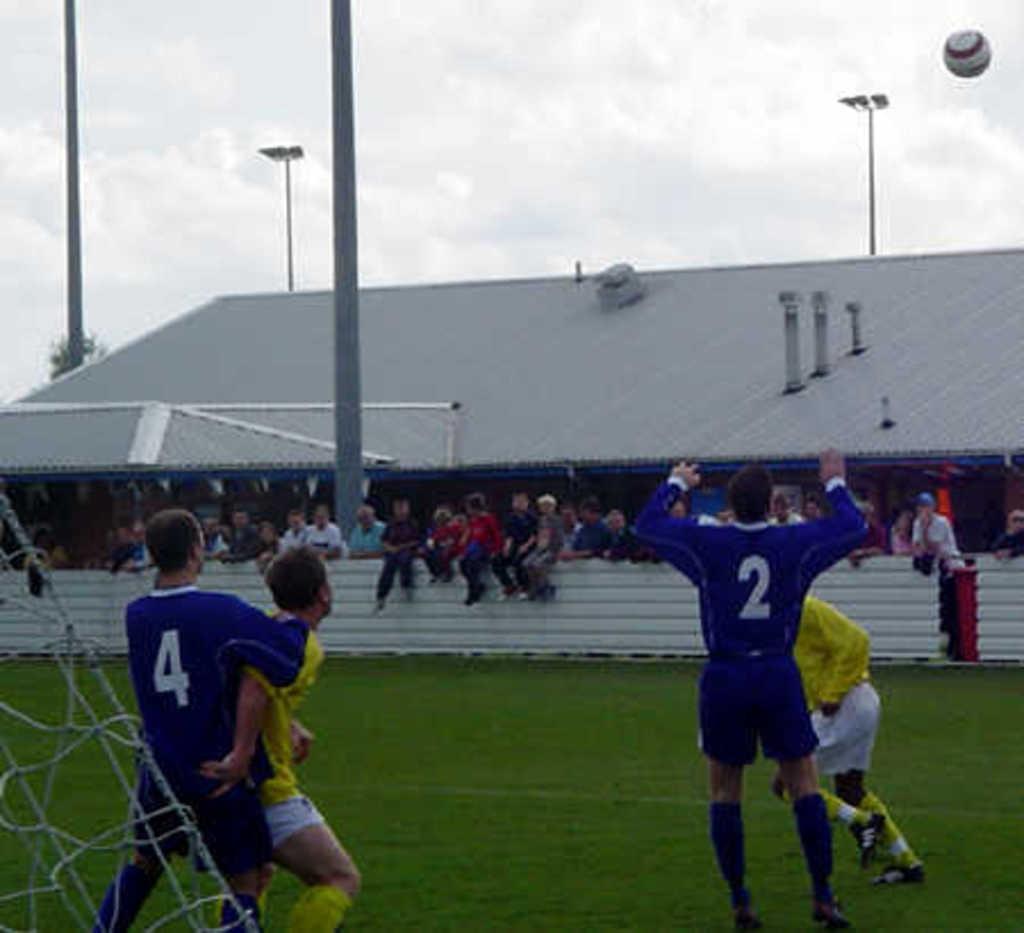Could you give a brief overview of what you see in this image? In the image we can see there are people standing on the ground. Behind there are people sitting on the wall and there is a building at the back. There is a ball flying in the sky. 